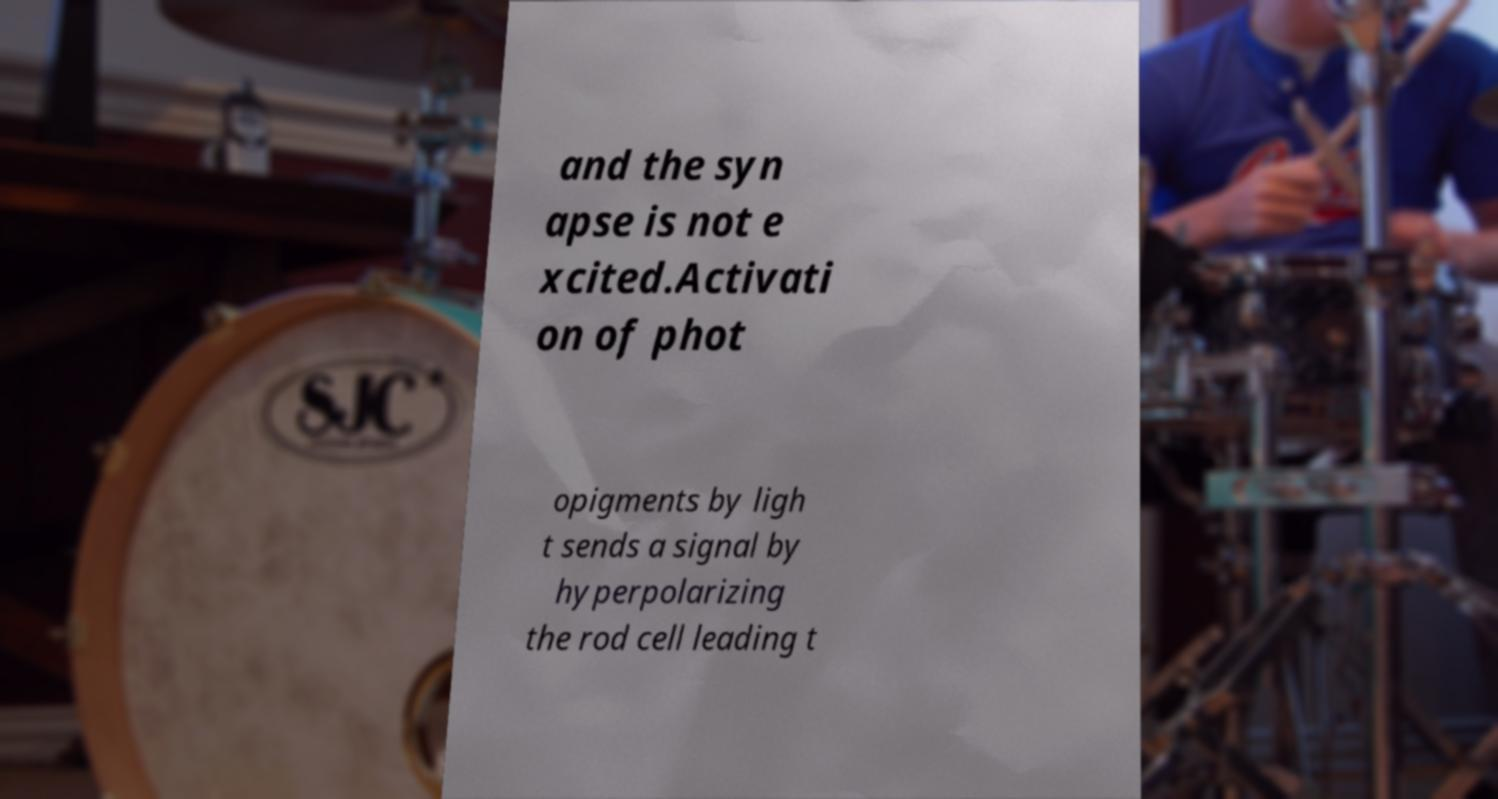There's text embedded in this image that I need extracted. Can you transcribe it verbatim? and the syn apse is not e xcited.Activati on of phot opigments by ligh t sends a signal by hyperpolarizing the rod cell leading t 